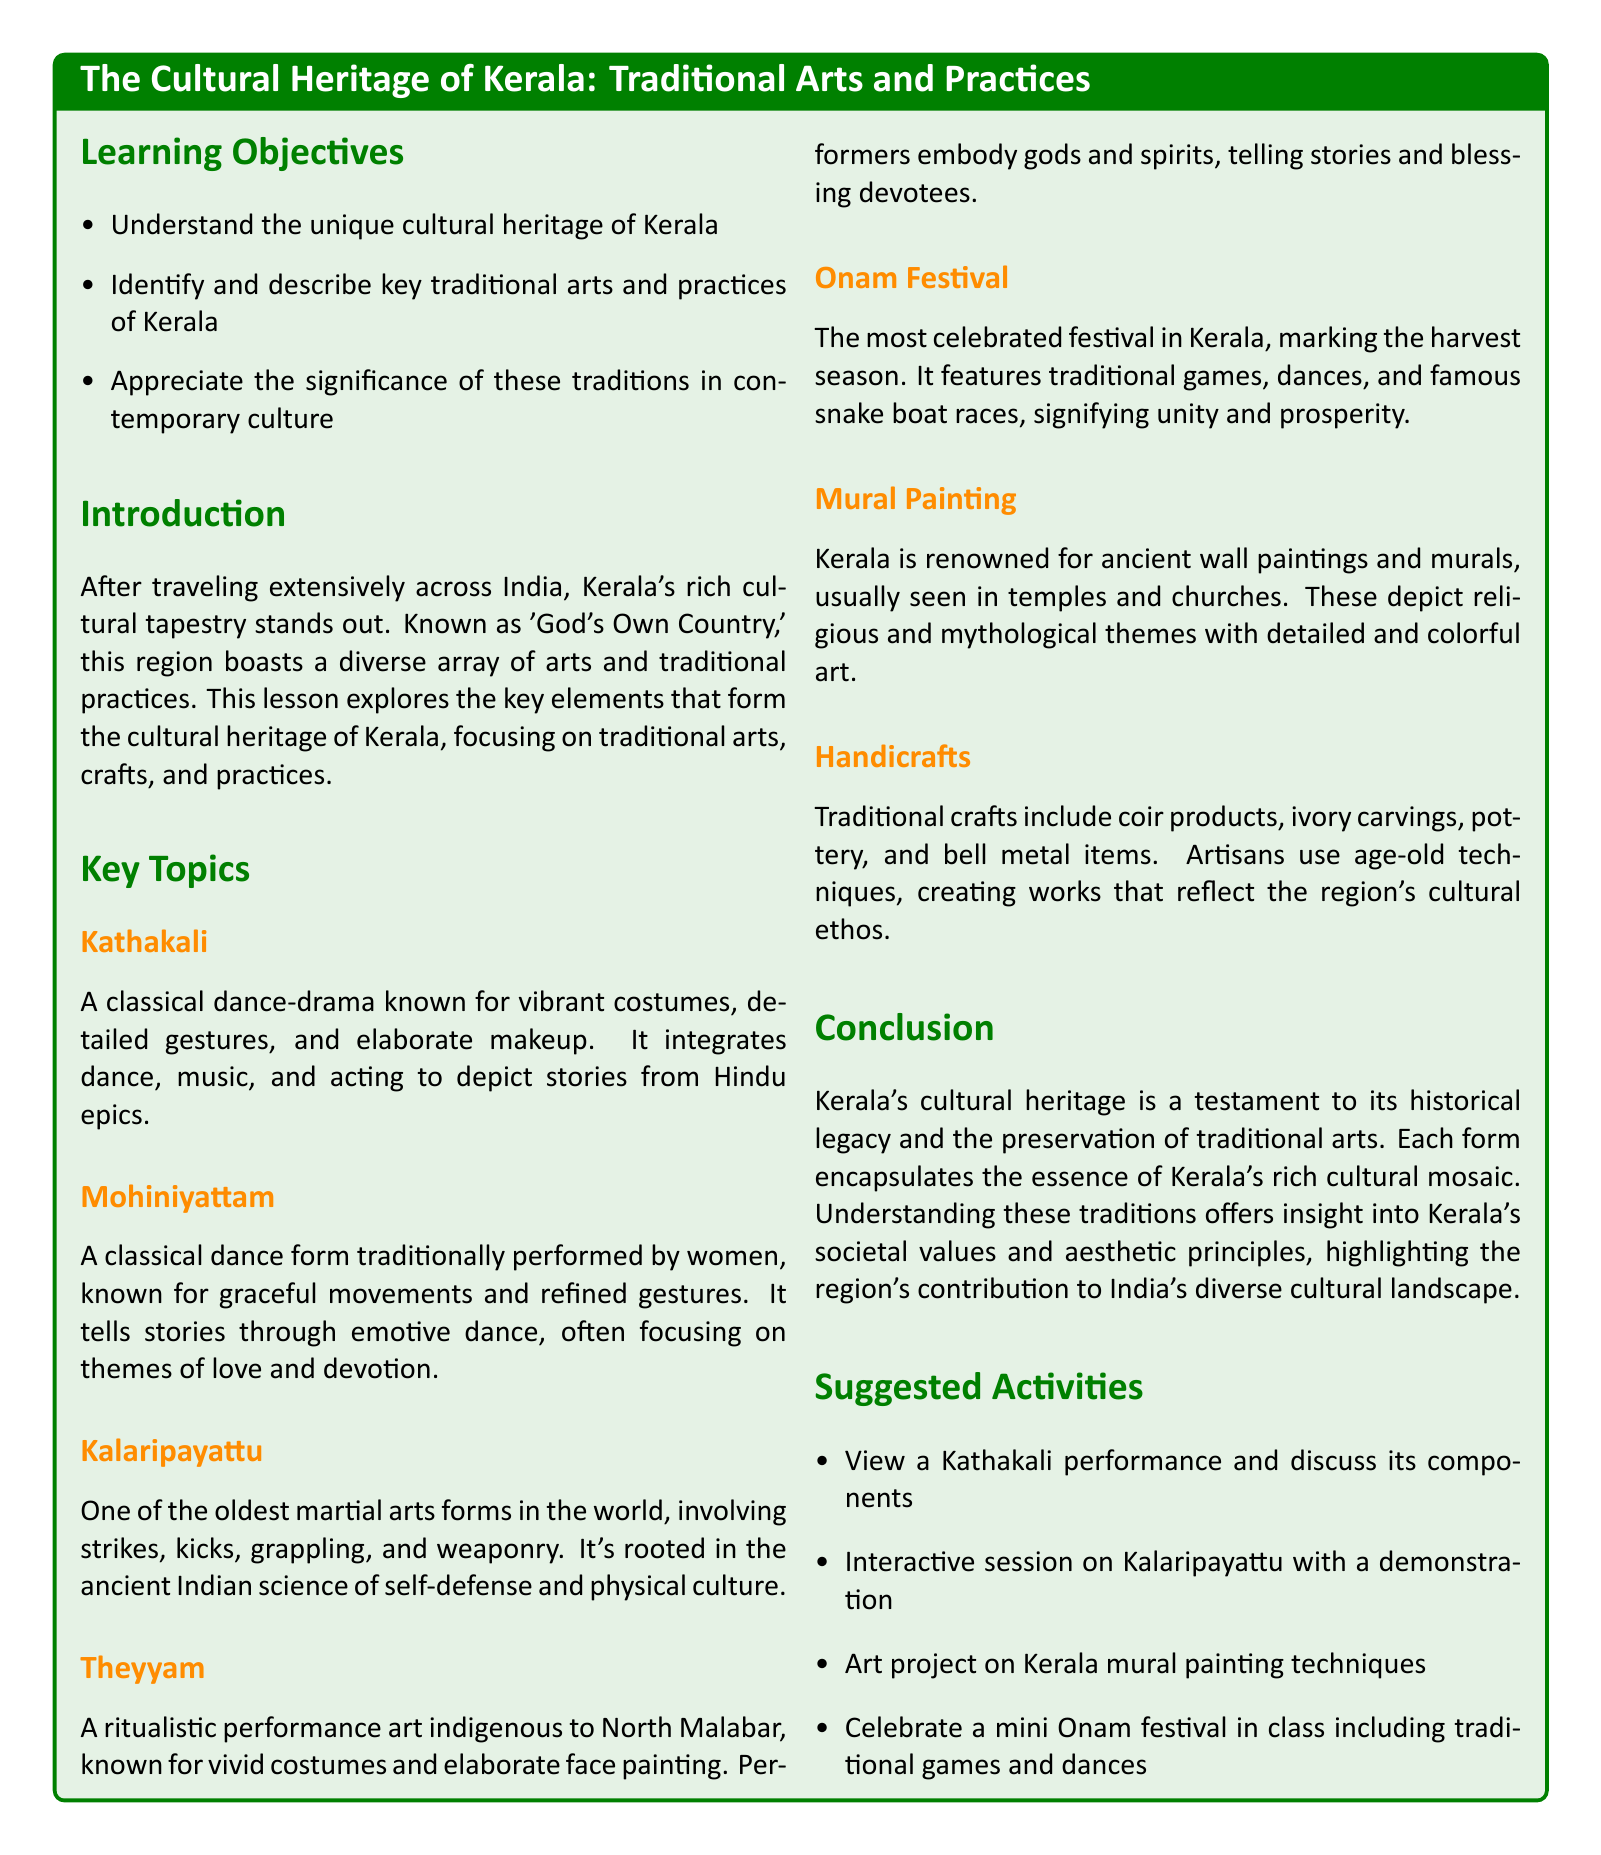What is the title of the lesson plan? The title of the lesson plan is stated prominently at the beginning of the document.
Answer: The Cultural Heritage of Kerala: Traditional Arts and Practices What is the main focus of the lesson? The main focus is detailed in the introduction and key topics sections of the document.
Answer: Traditional arts and practices of Kerala How many key topics are listed in the document? The number of key topics can be counted in the section under "Key Topics."
Answer: Seven What is the classical dance form performed by women? This information can be found in the description of the traditional dance forms listed in the document.
Answer: Mohiniyattam What is the most celebrated festival in Kerala? The festival is specifically mentioned and described in the "Key Topics" section of the document.
Answer: Onam Festival What traditional martial art form is mentioned in the document? The martial art form is listed under the key topics section, providing a specific name.
Answer: Kalaripayattu What type of painting is Kerala renowned for? This question refers to information provided in the key topics about the art forms in Kerala.
Answer: Mural Painting What is one suggested activity from the lesson plan? Suggested activities are listed at the end of the document.
Answer: View a Kathakali performance What does Theyyam represent in the cultural heritage of Kerala? The document provides a description of Theyyam's significance within the cultural context.
Answer: Ritualistic performance art 